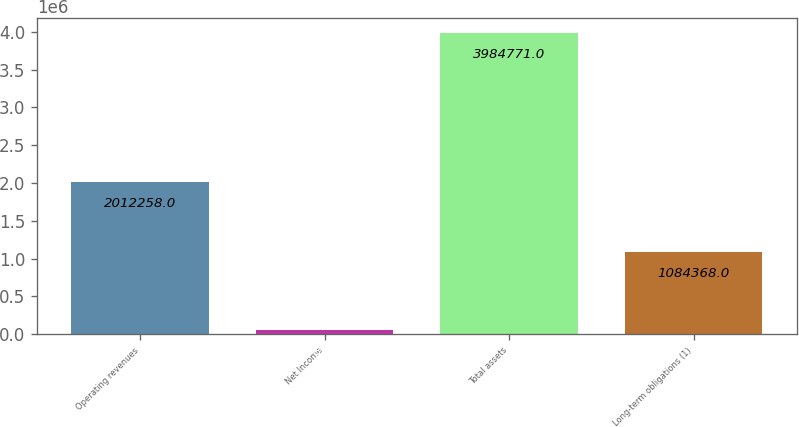<chart> <loc_0><loc_0><loc_500><loc_500><bar_chart><fcel>Operating revenues<fcel>Net Income<fcel>Total assets<fcel>Long-term obligations (1)<nl><fcel>2.01226e+06<fcel>57895<fcel>3.98477e+06<fcel>1.08437e+06<nl></chart> 